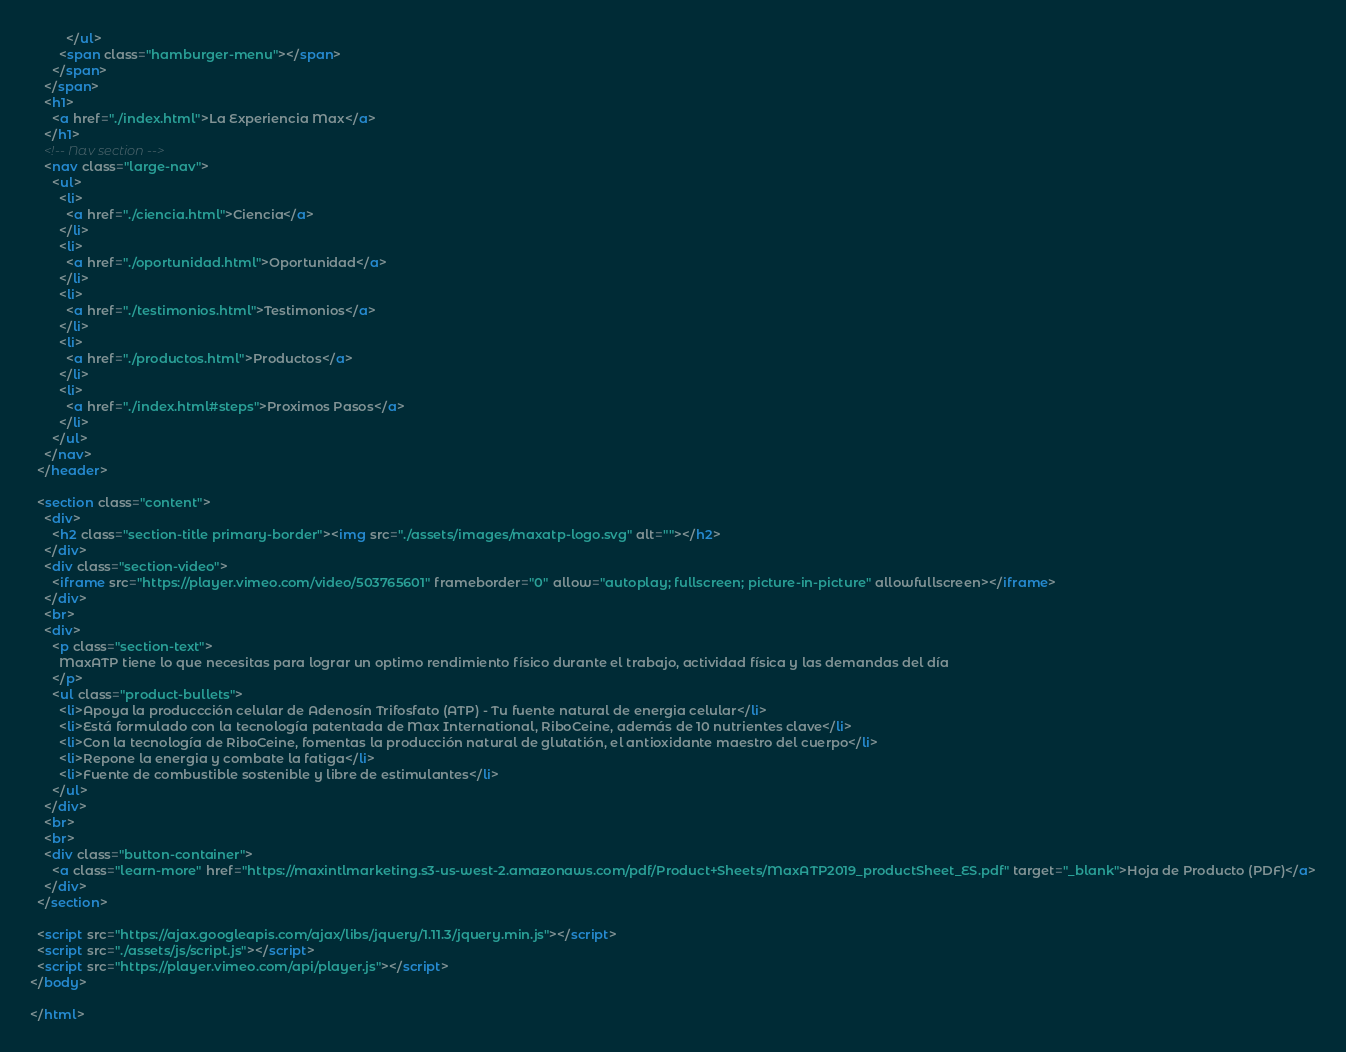<code> <loc_0><loc_0><loc_500><loc_500><_HTML_>          </ul>
        <span class="hamburger-menu"></span>
      </span>
    </span>
    <h1>
      <a href="./index.html">La Experiencia Max</a>
    </h1>
    <!-- Nav section -->
    <nav class="large-nav">
      <ul>
        <li>
          <a href="./ciencia.html">Ciencia</a>
        </li>
        <li>
          <a href="./oportunidad.html">Oportunidad</a>
        </li>
        <li>
          <a href="./testimonios.html">Testimonios</a>
        </li>
        <li>
          <a href="./productos.html">Productos</a>
        </li>
        <li>
          <a href="./index.html#steps">Proximos Pasos</a>
        </li>
      </ul>
    </nav>
  </header>

  <section class="content">
    <div>
      <h2 class="section-title primary-border"><img src="./assets/images/maxatp-logo.svg" alt=""></h2>
    </div>
    <div class="section-video">
      <iframe src="https://player.vimeo.com/video/503765601" frameborder="0" allow="autoplay; fullscreen; picture-in-picture" allowfullscreen></iframe>
    </div>
    <br>
    <div>
      <p class="section-text">
        MaxATP tiene lo que necesitas para lograr un optimo rendimiento físico durante el trabajo, actividad física y las demandas del día
      </p>
      <ul class="product-bullets">
        <li>Apoya la produccción celular de Adenosín Trifosfato (ATP) - Tu fuente natural de energia celular</li>
        <li>Está formulado con la tecnología patentada de Max International, RiboCeine, además de 10 nutrientes clave</li>
        <li>Con la tecnología de RiboCeine, fomentas la producción natural de glutatión, el antioxidante maestro del cuerpo</li>
        <li>Repone la energia y combate la fatiga</li>
        <li>Fuente de combustible sostenible y libre de estimulantes</li>
      </ul>
    </div>
    <br>
    <br>
    <div class="button-container">
      <a class="learn-more" href="https://maxintlmarketing.s3-us-west-2.amazonaws.com/pdf/Product+Sheets/MaxATP2019_productSheet_ES.pdf" target="_blank">Hoja de Producto (PDF)</a>
    </div>
  </section>

  <script src="https://ajax.googleapis.com/ajax/libs/jquery/1.11.3/jquery.min.js"></script>
  <script src="./assets/js/script.js"></script>
  <script src="https://player.vimeo.com/api/player.js"></script>
</body>

</html></code> 